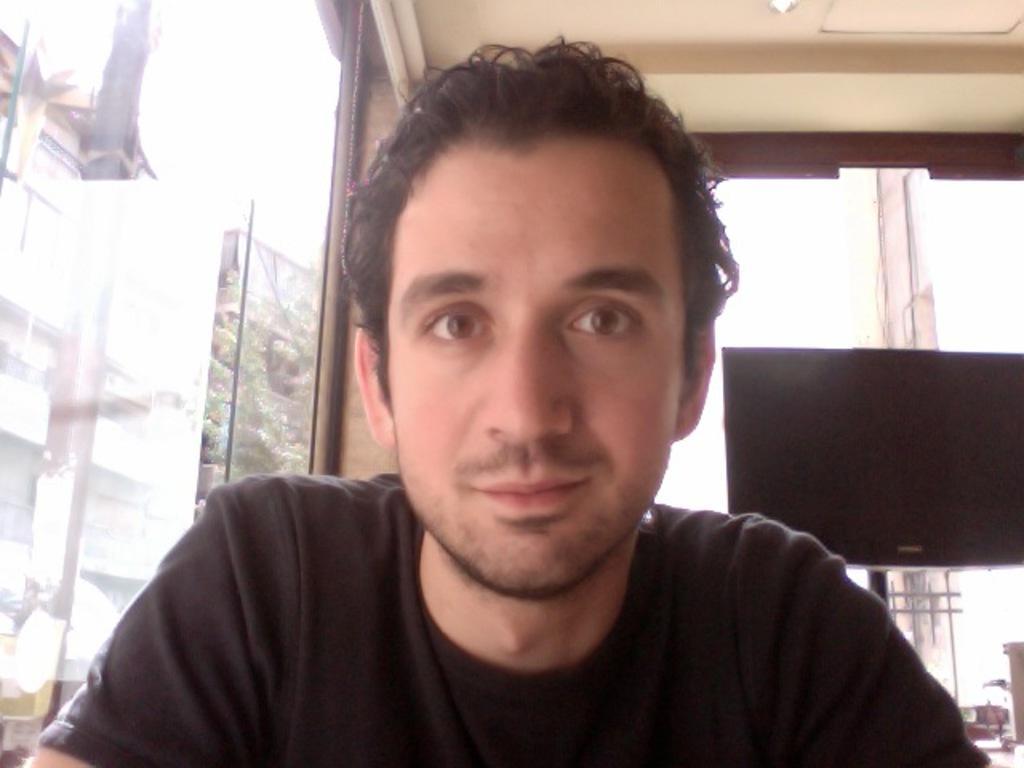Please provide a concise description of this image. In the foreground of this image, there is a man in black T shirt and behind him, there are glass walls and a screen. In the background, there are buildings and it seems like a tree and the sky. 